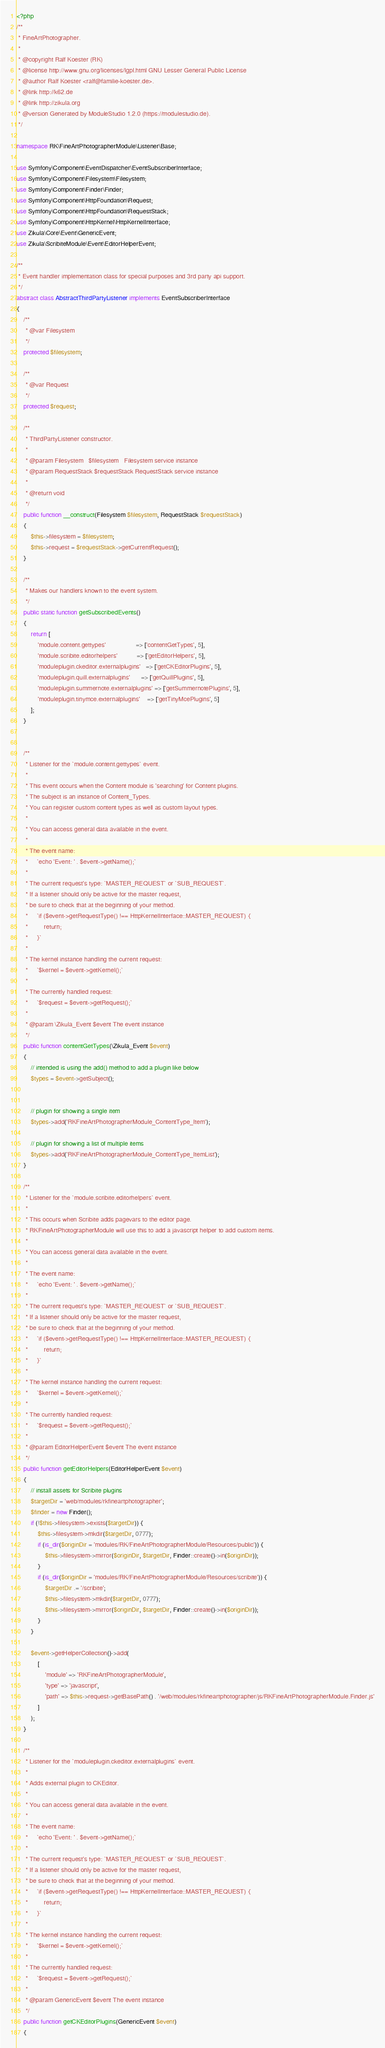<code> <loc_0><loc_0><loc_500><loc_500><_PHP_><?php
/**
 * FineArtPhotographer.
 *
 * @copyright Ralf Koester (RK)
 * @license http://www.gnu.org/licenses/lgpl.html GNU Lesser General Public License
 * @author Ralf Koester <ralf@familie-koester.de>.
 * @link http://k62.de
 * @link http://zikula.org
 * @version Generated by ModuleStudio 1.2.0 (https://modulestudio.de).
 */

namespace RK\FineArtPhotographerModule\Listener\Base;

use Symfony\Component\EventDispatcher\EventSubscriberInterface;
use Symfony\Component\Filesystem\Filesystem;
use Symfony\Component\Finder\Finder;
use Symfony\Component\HttpFoundation\Request;
use Symfony\Component\HttpFoundation\RequestStack;
use Symfony\Component\HttpKernel\HttpKernelInterface;
use Zikula\Core\Event\GenericEvent;
use Zikula\ScribiteModule\Event\EditorHelperEvent;

/**
 * Event handler implementation class for special purposes and 3rd party api support.
 */
abstract class AbstractThirdPartyListener implements EventSubscriberInterface
{
    /**
     * @var Filesystem
     */
    protected $filesystem;
    
    /**
     * @var Request
     */
    protected $request;
    
    /**
     * ThirdPartyListener constructor.
     *
     * @param Filesystem   $filesystem   Filesystem service instance
     * @param RequestStack $requestStack RequestStack service instance
     *
     * @return void
     */
    public function __construct(Filesystem $filesystem, RequestStack $requestStack)
    {
        $this->filesystem = $filesystem;
        $this->request = $requestStack->getCurrentRequest();
    }
    
    /**
     * Makes our handlers known to the event system.
     */
    public static function getSubscribedEvents()
    {
        return [
            'module.content.gettypes'                 => ['contentGetTypes', 5],
            'module.scribite.editorhelpers'           => ['getEditorHelpers', 5],
            'moduleplugin.ckeditor.externalplugins'   => ['getCKEditorPlugins', 5],
            'moduleplugin.quill.externalplugins'      => ['getQuillPlugins', 5],
            'moduleplugin.summernote.externalplugins' => ['getSummernotePlugins', 5],
            'moduleplugin.tinymce.externalplugins'    => ['getTinyMcePlugins', 5]
        ];
    }
    
    
    /**
     * Listener for the `module.content.gettypes` event.
     *
     * This event occurs when the Content module is 'searching' for Content plugins.
     * The subject is an instance of Content_Types.
     * You can register custom content types as well as custom layout types.
     *
     * You can access general data available in the event.
     *
     * The event name:
     *     `echo 'Event: ' . $event->getName();`
     *
     * The current request's type: `MASTER_REQUEST` or `SUB_REQUEST`.
     * If a listener should only be active for the master request,
     * be sure to check that at the beginning of your method.
     *     `if ($event->getRequestType() !== HttpKernelInterface::MASTER_REQUEST) {
     *         return;
     *     }`
     *
     * The kernel instance handling the current request:
     *     `$kernel = $event->getKernel();`
     *
     * The currently handled request:
     *     `$request = $event->getRequest();`
     *
     * @param \Zikula_Event $event The event instance
     */
    public function contentGetTypes(\Zikula_Event $event)
    {
        // intended is using the add() method to add a plugin like below
        $types = $event->getSubject();
        
        
        // plugin for showing a single item
        $types->add('RKFineArtPhotographerModule_ContentType_Item');
        
        // plugin for showing a list of multiple items
        $types->add('RKFineArtPhotographerModule_ContentType_ItemList');
    }
    
    /**
     * Listener for the `module.scribite.editorhelpers` event.
     *
     * This occurs when Scribite adds pagevars to the editor page.
     * RKFineArtPhotographerModule will use this to add a javascript helper to add custom items.
     *
     * You can access general data available in the event.
     *
     * The event name:
     *     `echo 'Event: ' . $event->getName();`
     *
     * The current request's type: `MASTER_REQUEST` or `SUB_REQUEST`.
     * If a listener should only be active for the master request,
     * be sure to check that at the beginning of your method.
     *     `if ($event->getRequestType() !== HttpKernelInterface::MASTER_REQUEST) {
     *         return;
     *     }`
     *
     * The kernel instance handling the current request:
     *     `$kernel = $event->getKernel();`
     *
     * The currently handled request:
     *     `$request = $event->getRequest();`
     *
     * @param EditorHelperEvent $event The event instance
     */
    public function getEditorHelpers(EditorHelperEvent $event)
    {
        // install assets for Scribite plugins
        $targetDir = 'web/modules/rkfineartphotographer';
        $finder = new Finder();
        if (!$this->filesystem->exists($targetDir)) {
            $this->filesystem->mkdir($targetDir, 0777);
            if (is_dir($originDir = 'modules/RK/FineArtPhotographerModule/Resources/public')) {
                $this->filesystem->mirror($originDir, $targetDir, Finder::create()->in($originDir));
            }
            if (is_dir($originDir = 'modules/RK/FineArtPhotographerModule/Resources/scribite')) {
                $targetDir .= '/scribite';
                $this->filesystem->mkdir($targetDir, 0777);
                $this->filesystem->mirror($originDir, $targetDir, Finder::create()->in($originDir));
            }
        }
    
        $event->getHelperCollection()->add(
            [
                'module' => 'RKFineArtPhotographerModule',
                'type' => 'javascript',
                'path' => $this->request->getBasePath() . '/web/modules/rkfineartphotographer/js/RKFineArtPhotographerModule.Finder.js'
            ]
        );
    }
    
    /**
     * Listener for the `moduleplugin.ckeditor.externalplugins` event.
     *
     * Adds external plugin to CKEditor.
     *
     * You can access general data available in the event.
     *
     * The event name:
     *     `echo 'Event: ' . $event->getName();`
     *
     * The current request's type: `MASTER_REQUEST` or `SUB_REQUEST`.
     * If a listener should only be active for the master request,
     * be sure to check that at the beginning of your method.
     *     `if ($event->getRequestType() !== HttpKernelInterface::MASTER_REQUEST) {
     *         return;
     *     }`
     *
     * The kernel instance handling the current request:
     *     `$kernel = $event->getKernel();`
     *
     * The currently handled request:
     *     `$request = $event->getRequest();`
     *
     * @param GenericEvent $event The event instance
     */
    public function getCKEditorPlugins(GenericEvent $event)
    {</code> 